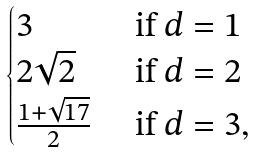Convert formula to latex. <formula><loc_0><loc_0><loc_500><loc_500>\begin{cases} 3 & \text { if } d = 1 \\ 2 \sqrt { 2 } & \text { if } d = 2 \\ \frac { 1 + \sqrt { 1 7 } } { 2 } & \text { if } d = 3 , \end{cases}</formula> 